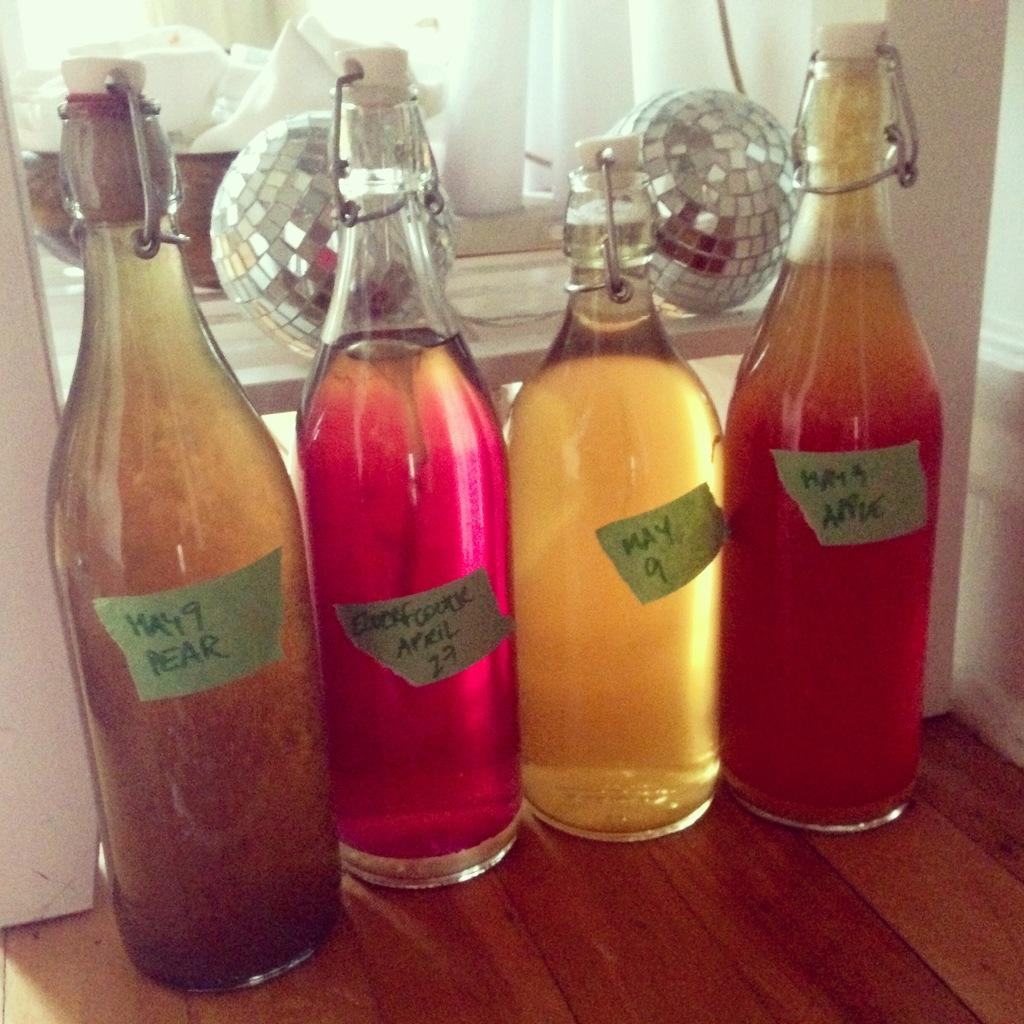Provide a one-sentence caption for the provided image. Some bottles of homemade drinks have tape labels on them that say May 9. 